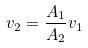Convert formula to latex. <formula><loc_0><loc_0><loc_500><loc_500>v _ { 2 } = \frac { A _ { 1 } } { A _ { 2 } } v _ { 1 }</formula> 